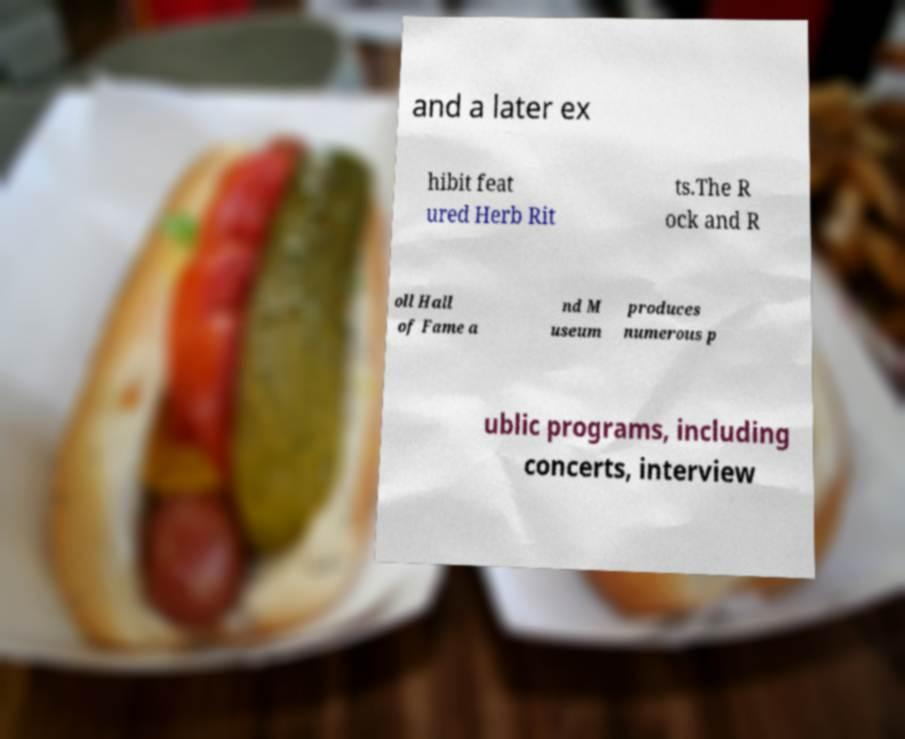Please read and relay the text visible in this image. What does it say? and a later ex hibit feat ured Herb Rit ts.The R ock and R oll Hall of Fame a nd M useum produces numerous p ublic programs, including concerts, interview 